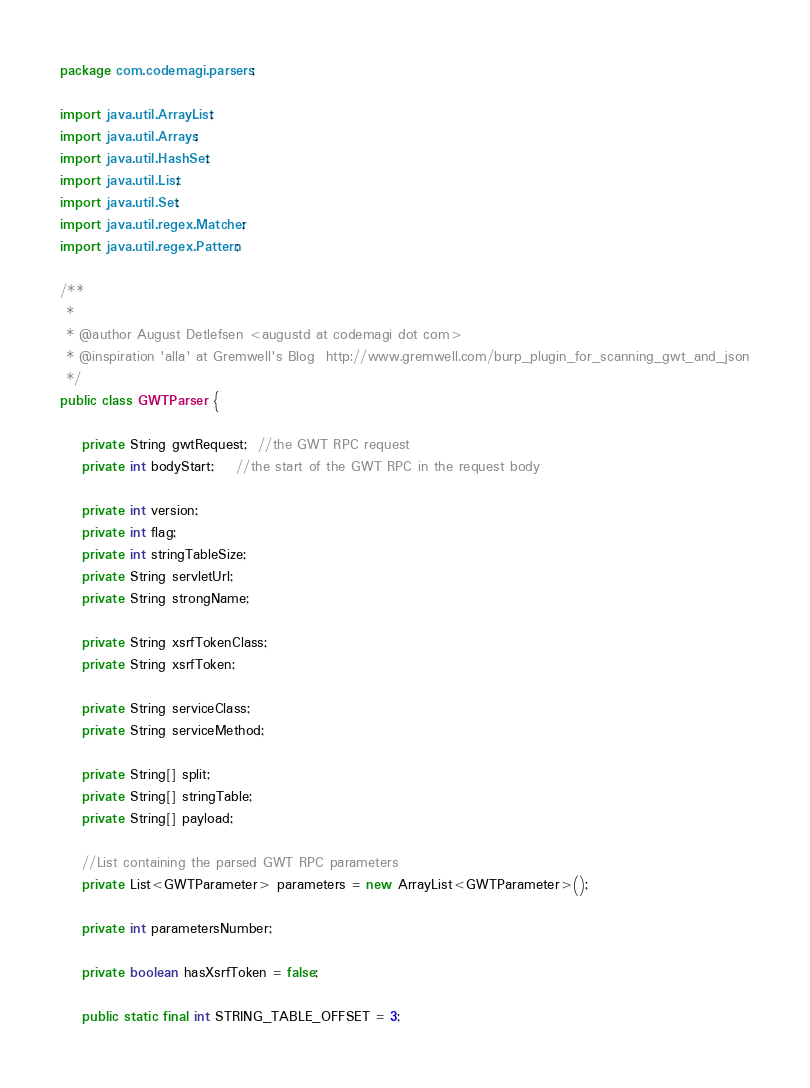<code> <loc_0><loc_0><loc_500><loc_500><_Java_>package com.codemagi.parsers;

import java.util.ArrayList;
import java.util.Arrays;
import java.util.HashSet;
import java.util.List;
import java.util.Set;
import java.util.regex.Matcher;
import java.util.regex.Pattern;

/**
 *
 * @author August Detlefsen <augustd at codemagi dot com>
 * @inspiration 'alla' at Gremwell's Blog  http://www.gremwell.com/burp_plugin_for_scanning_gwt_and_json
 */
public class GWTParser {

    private String gwtRequest;  //the GWT RPC request
    private int bodyStart;	//the start of the GWT RPC in the request body

    private int version;
    private int flag;
    private int stringTableSize;
    private String servletUrl;
    private String strongName;
    
    private String xsrfTokenClass;
    private String xsrfToken;
    
    private String serviceClass;
    private String serviceMethod;

    private String[] split;
    private String[] stringTable;
    private String[] payload;

    //List containing the parsed GWT RPC parameters 
    private List<GWTParameter> parameters = new ArrayList<GWTParameter>();
    
    private int parametersNumber;
    
    private boolean hasXsrfToken = false;
    
    public static final int STRING_TABLE_OFFSET = 3;</code> 